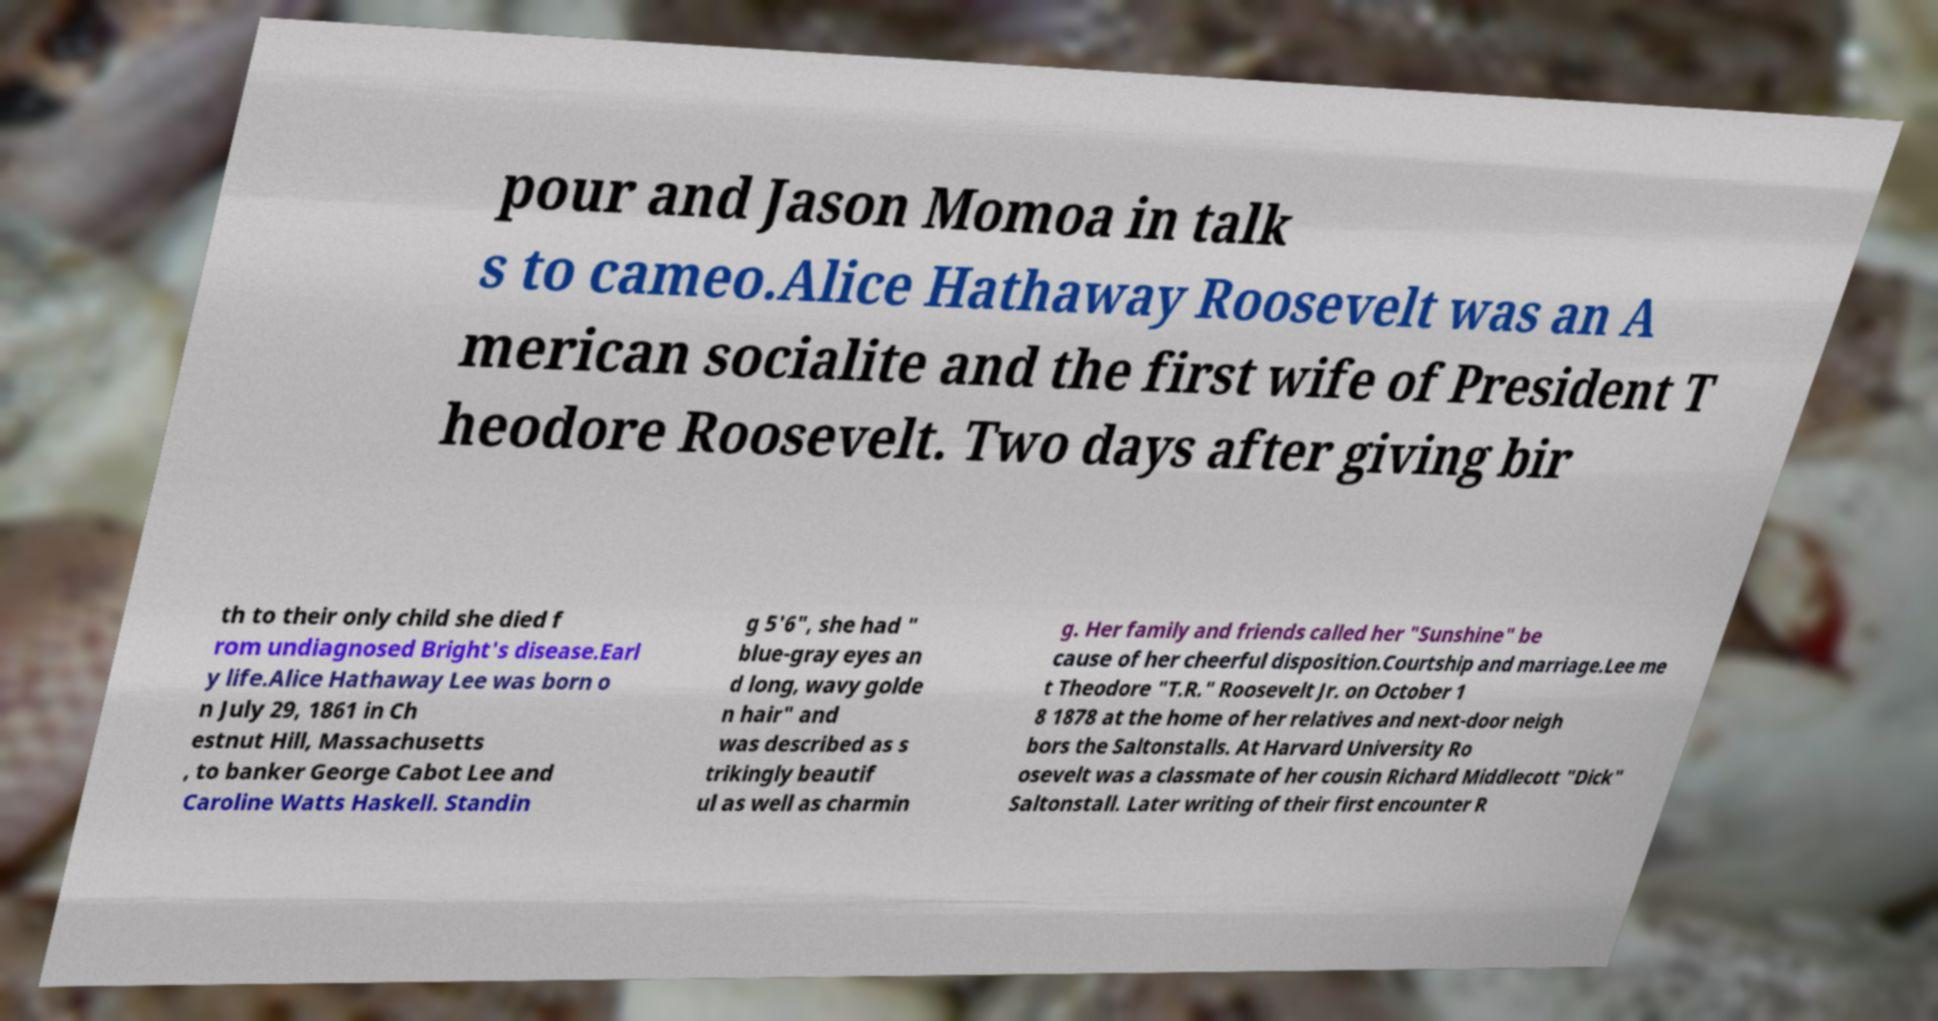For documentation purposes, I need the text within this image transcribed. Could you provide that? pour and Jason Momoa in talk s to cameo.Alice Hathaway Roosevelt was an A merican socialite and the first wife of President T heodore Roosevelt. Two days after giving bir th to their only child she died f rom undiagnosed Bright's disease.Earl y life.Alice Hathaway Lee was born o n July 29, 1861 in Ch estnut Hill, Massachusetts , to banker George Cabot Lee and Caroline Watts Haskell. Standin g 5'6", she had " blue-gray eyes an d long, wavy golde n hair" and was described as s trikingly beautif ul as well as charmin g. Her family and friends called her "Sunshine" be cause of her cheerful disposition.Courtship and marriage.Lee me t Theodore "T.R." Roosevelt Jr. on October 1 8 1878 at the home of her relatives and next-door neigh bors the Saltonstalls. At Harvard University Ro osevelt was a classmate of her cousin Richard Middlecott "Dick" Saltonstall. Later writing of their first encounter R 